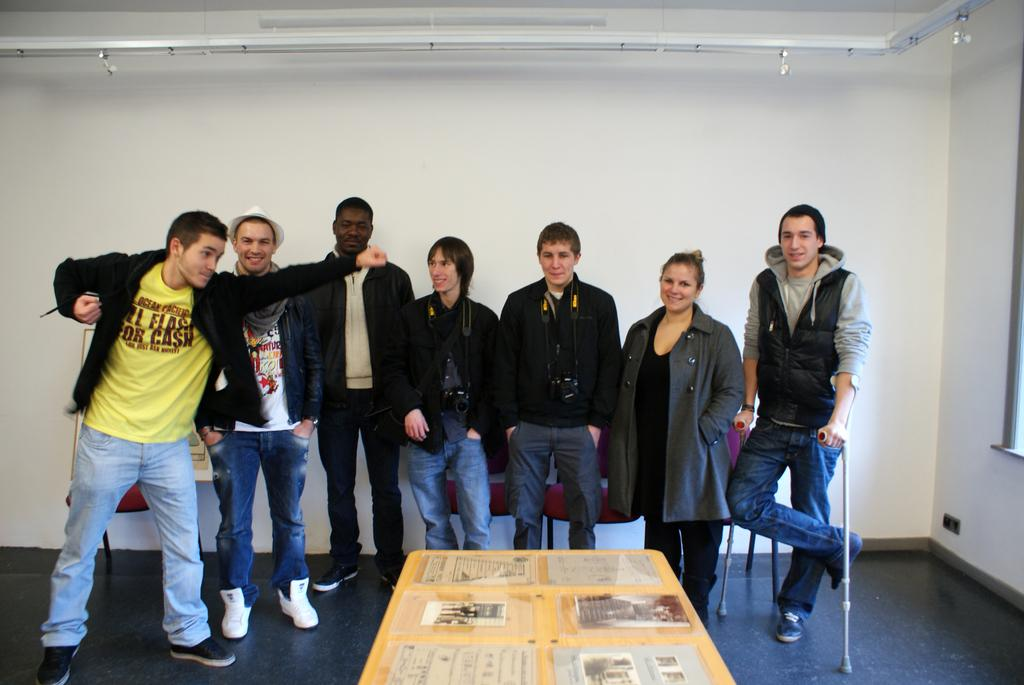How many people are in the image? There are persons visible in the image, but the exact number cannot be determined from the provided facts. What is behind the persons in the image? Chairs are visible behind the persons in the image. What is in front of the persons in the image? There is a table in front of the persons in the image. What items can be seen on the table? Books are present on the table in the image. Can you hear a bell ringing in the image? There is no mention of a bell in the image, so it cannot be determined if it is ringing or present. 